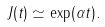<formula> <loc_0><loc_0><loc_500><loc_500>J ( t ) \simeq \exp ( \alpha t ) .</formula> 